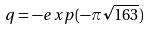<formula> <loc_0><loc_0><loc_500><loc_500>q = - e x p ( - \pi \sqrt { 1 6 3 } )</formula> 